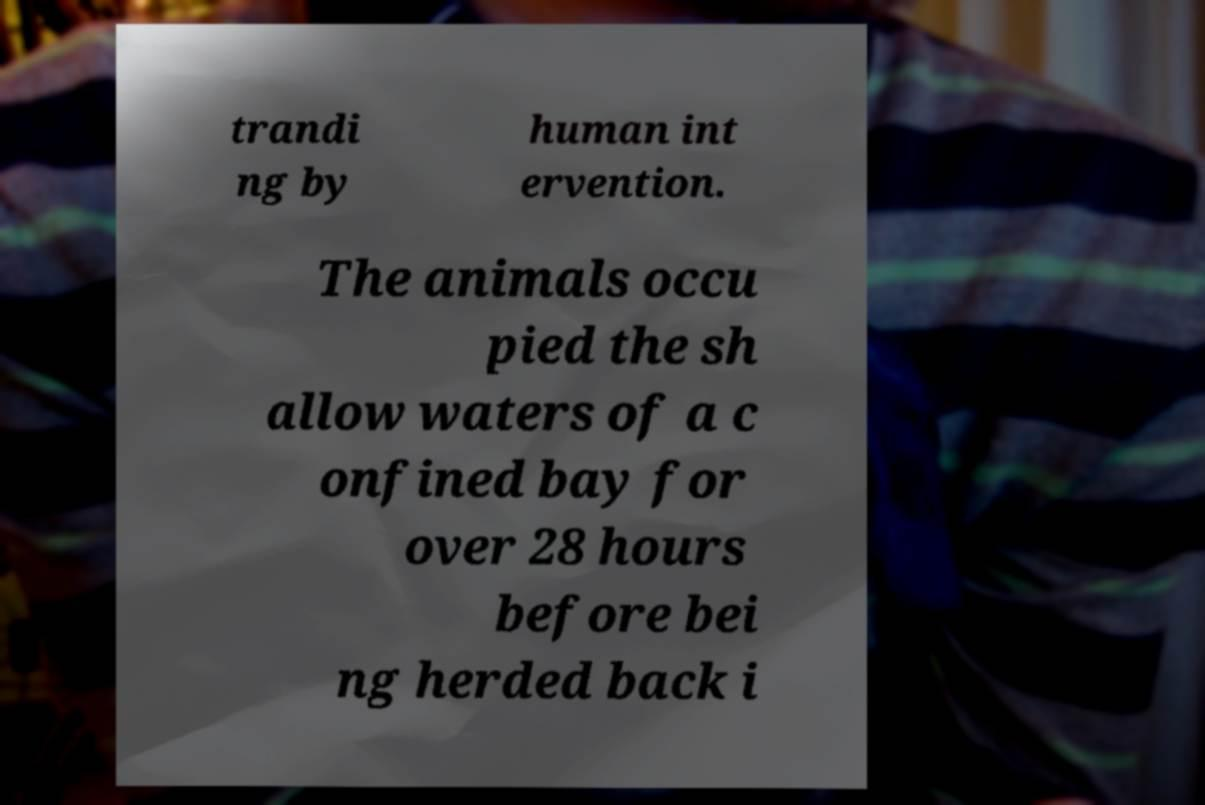There's text embedded in this image that I need extracted. Can you transcribe it verbatim? trandi ng by human int ervention. The animals occu pied the sh allow waters of a c onfined bay for over 28 hours before bei ng herded back i 